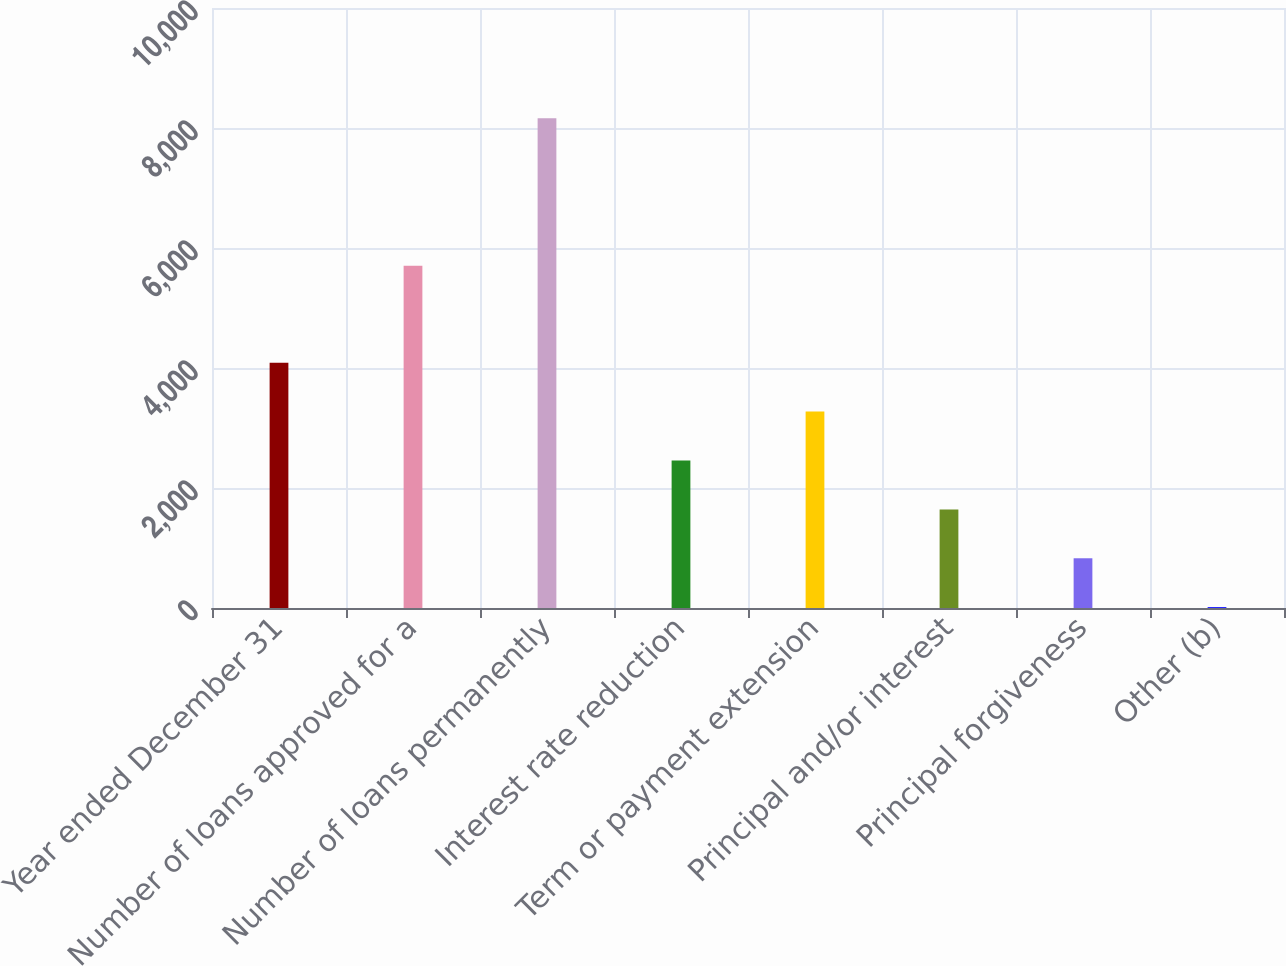Convert chart. <chart><loc_0><loc_0><loc_500><loc_500><bar_chart><fcel>Year ended December 31<fcel>Number of loans approved for a<fcel>Number of loans permanently<fcel>Interest rate reduction<fcel>Term or payment extension<fcel>Principal and/or interest<fcel>Principal forgiveness<fcel>Other (b)<nl><fcel>4088<fcel>5705<fcel>8162<fcel>2458.4<fcel>3273.2<fcel>1643.6<fcel>828.8<fcel>14<nl></chart> 